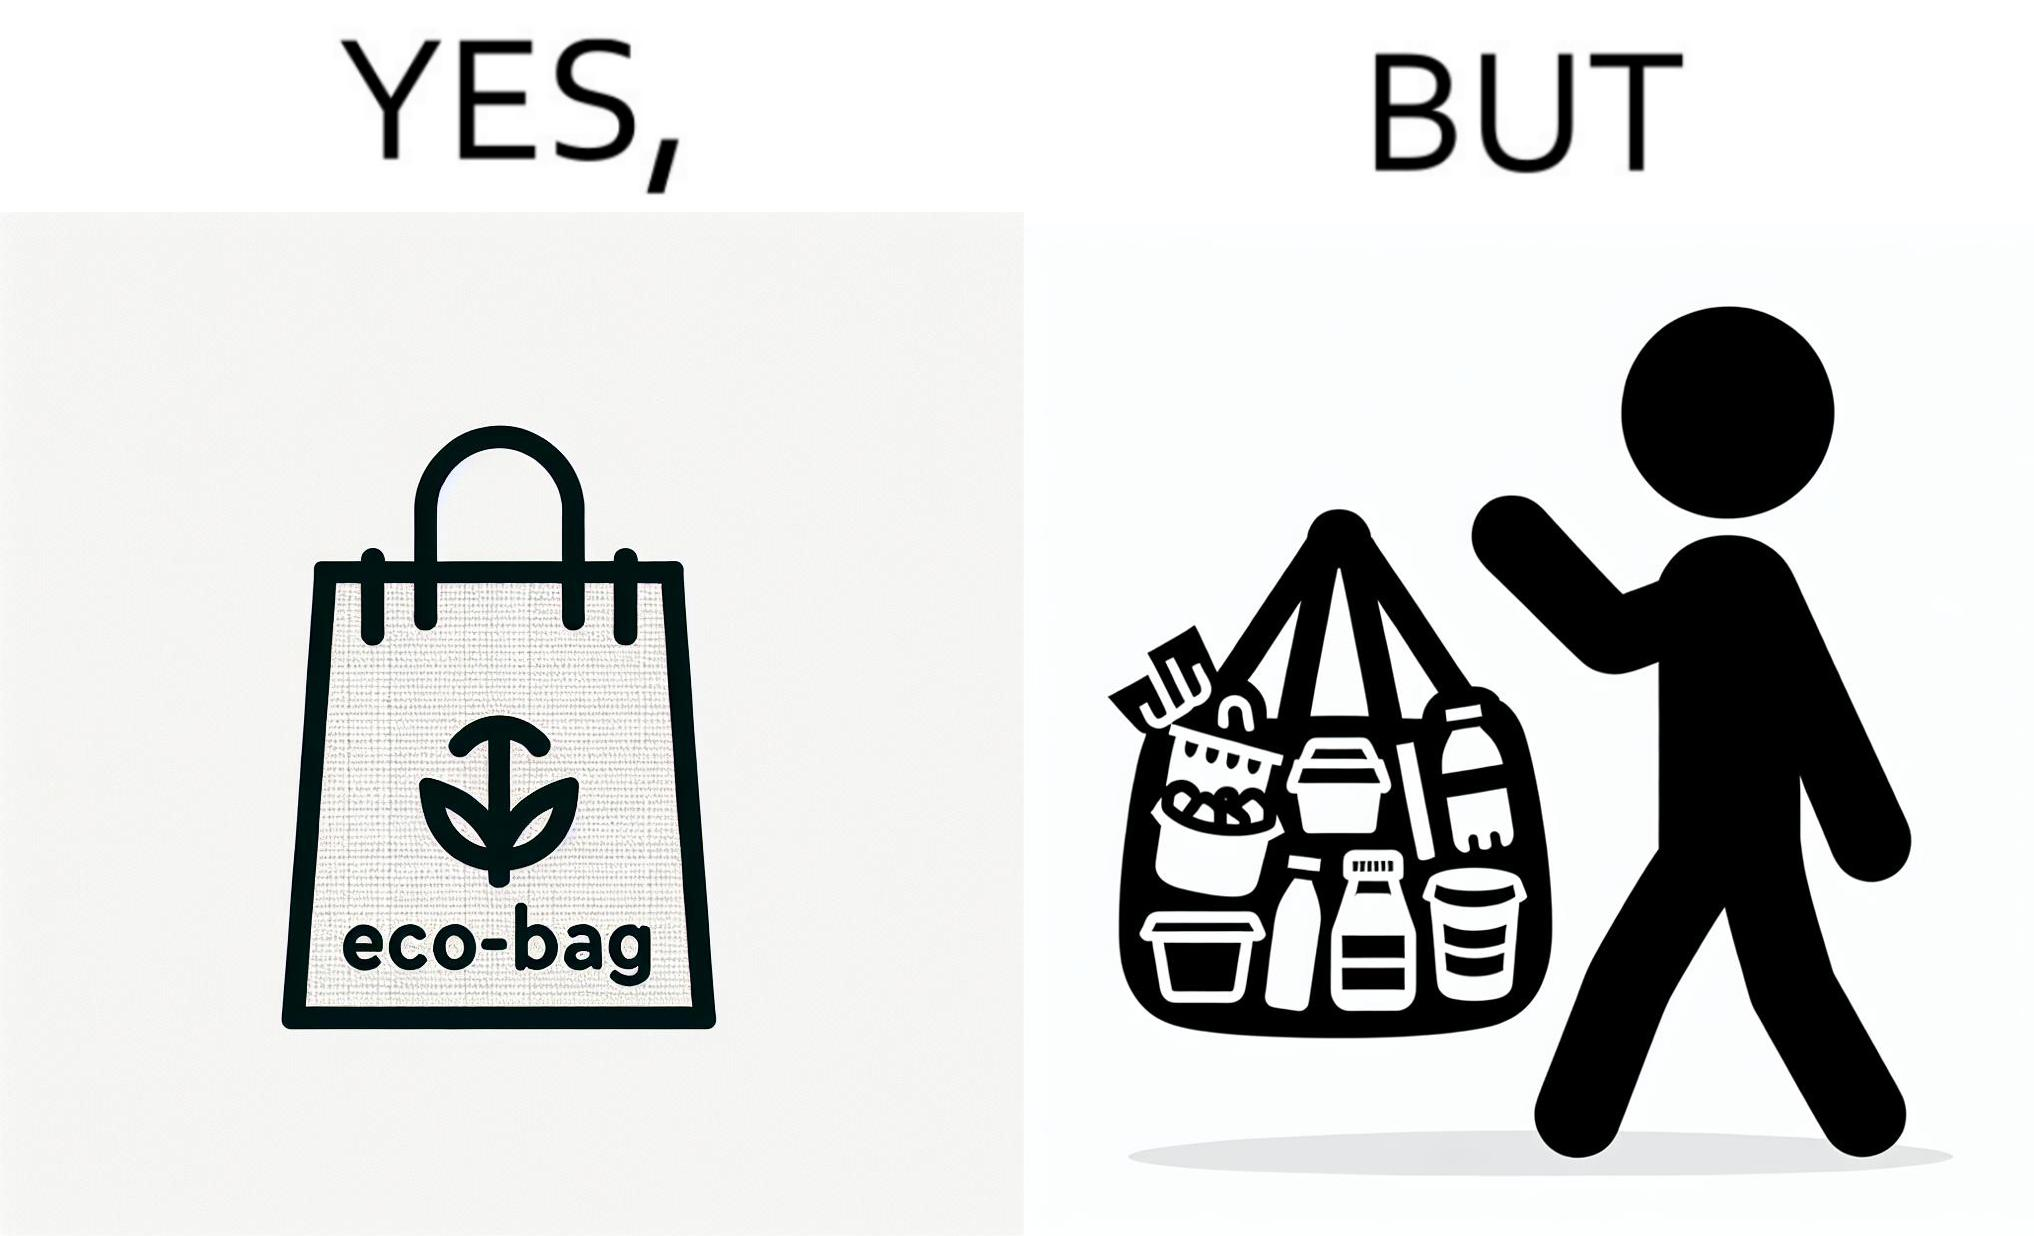Is this a satirical image? Yes, this image is satirical. 